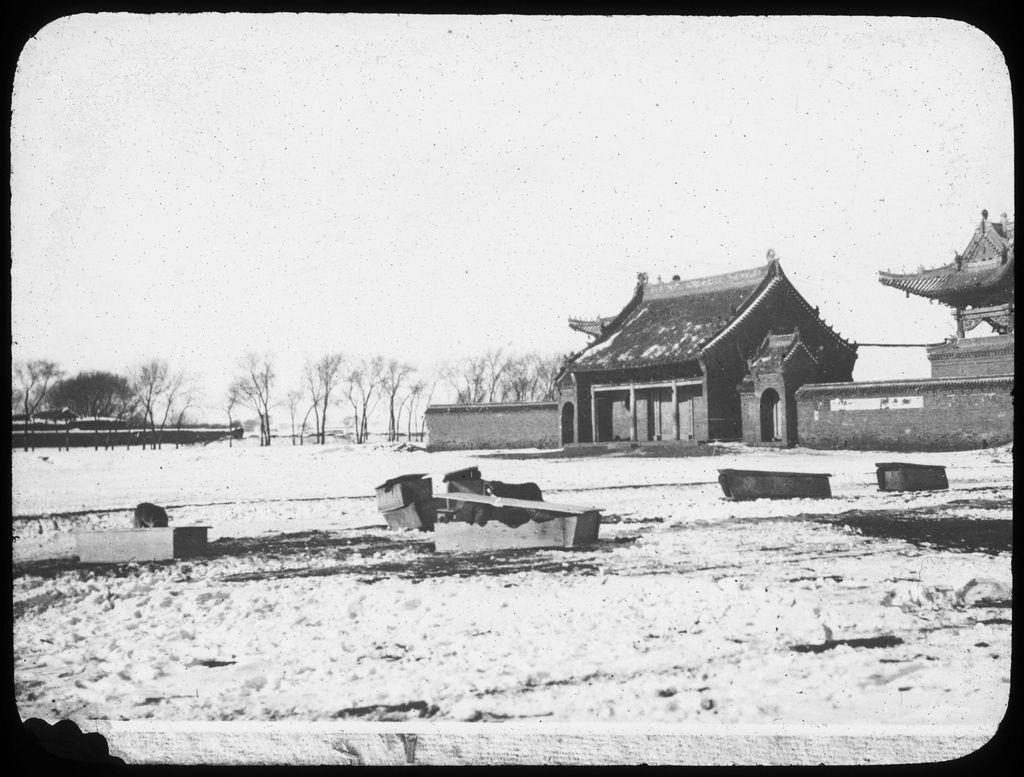Describe this image in one or two sentences. In this picture, I can see couple of houses and trees and few boxes on the ground. 